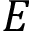Convert formula to latex. <formula><loc_0><loc_0><loc_500><loc_500>E</formula> 